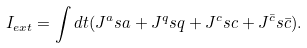Convert formula to latex. <formula><loc_0><loc_0><loc_500><loc_500>I _ { e x t } = \int d t ( J ^ { a } s a + J ^ { q } s q + J ^ { c } s c + J ^ { \bar { c } } s \bar { c } ) .</formula> 